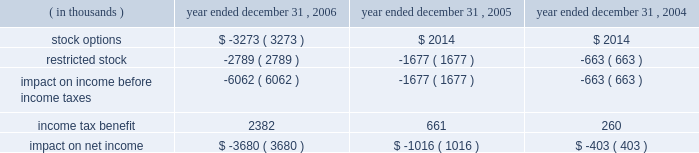Packaging corporation of america notes to consolidated financial statements ( continued ) december 31 , 2006 4 .
Stock-based compensation ( continued ) same period was $ 1988000 lower , than if it had continued to account for share-based compensation under apb no .
25 .
Basic and diluted earnings per share for the year ended december 31 , 2006 were both $ 0.02 lower than if the company had continued to account for share-based compensation under apb no .
25 .
Prior to the adoption of sfas no .
123 ( r ) , the company presented all tax benefits of deductions resulting from share-based payment arrangements as operating cash flows in the statements of cash flows .
Sfas no .
123 ( r ) requires the cash flows resulting from the tax benefits from tax deductions in excess of the compensation cost recognized for those share awards ( excess tax benefits ) to be classified as financing cash flows .
The excess tax benefit of $ 2885000 classified as a financing cash inflow for the year ended december 31 , 2006 would have been classified as an operating cash inflow if the company had not adopted sfas no .
123 ( r ) .
As a result of adopting sfas no 123 ( r ) , unearned compensation previously recorded in stockholders 2019 equity was reclassified against additional paid in capital on january 1 , 2006 .
All stock-based compensation expense not recognized as of december 31 , 2005 and compensation expense related to post 2005 grants of stock options and amortization of restricted stock will be recorded directly to additional paid in capital .
Compensation expense for stock options and restricted stock recognized in the statements of income for the year ended december 31 , 2006 , 2005 and 2004 was as follows : year ended december 31 , ( in thousands ) 2006 2005 2004 .

What percent did restricted stock expense increase from 2004 to 2005? 
Computations: (663 / 1677)
Answer: 0.39535. 